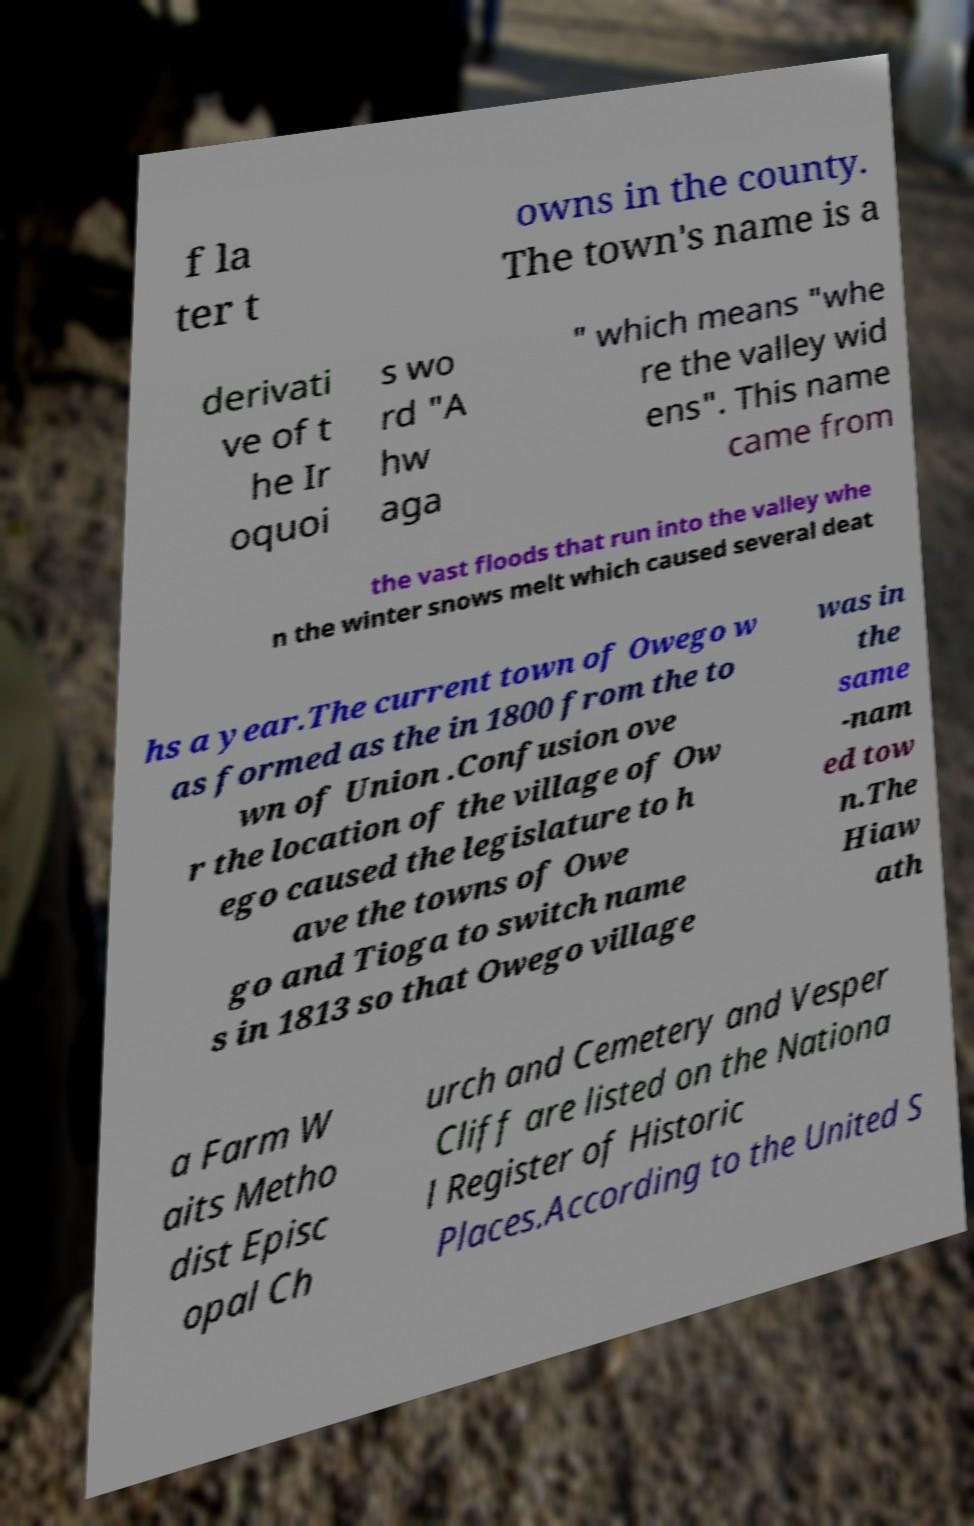Please read and relay the text visible in this image. What does it say? f la ter t owns in the county. The town's name is a derivati ve of t he Ir oquoi s wo rd "A hw aga " which means "whe re the valley wid ens". This name came from the vast floods that run into the valley whe n the winter snows melt which caused several deat hs a year.The current town of Owego w as formed as the in 1800 from the to wn of Union .Confusion ove r the location of the village of Ow ego caused the legislature to h ave the towns of Owe go and Tioga to switch name s in 1813 so that Owego village was in the same -nam ed tow n.The Hiaw ath a Farm W aits Metho dist Episc opal Ch urch and Cemetery and Vesper Cliff are listed on the Nationa l Register of Historic Places.According to the United S 